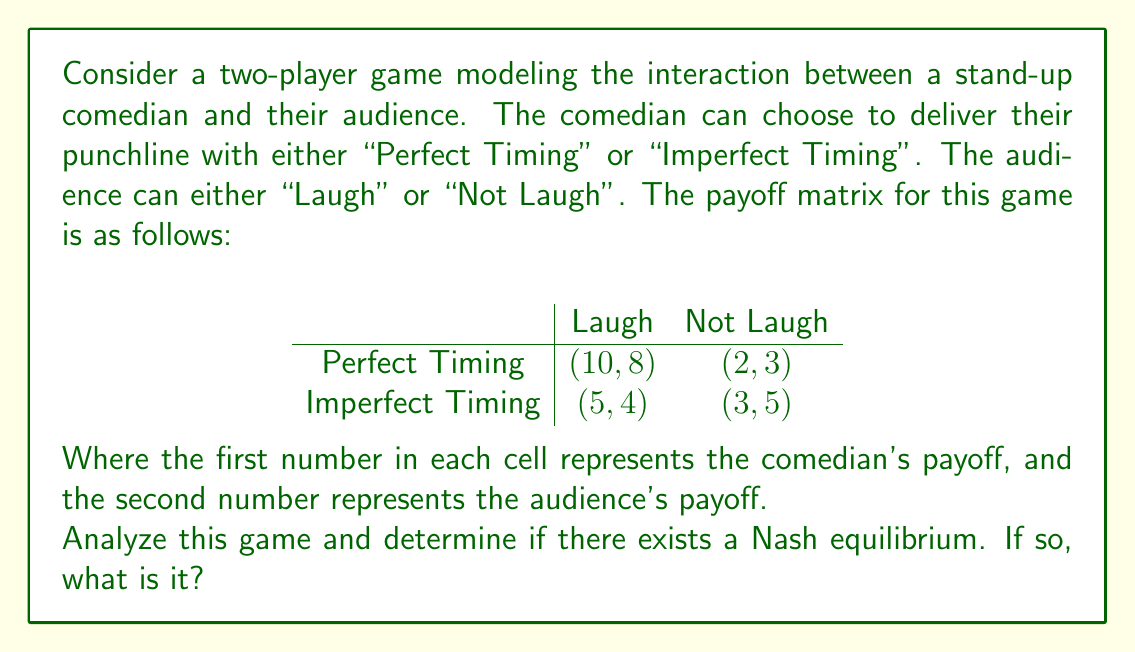Teach me how to tackle this problem. To solve this problem, we need to analyze the game using the concept of Nash equilibrium. A Nash equilibrium occurs when neither player can unilaterally improve their payoff by changing their strategy.

Let's examine each player's best responses:

1. Comedian's perspective:
   - If the audience laughs, Perfect Timing (10) > Imperfect Timing (5)
   - If the audience doesn't laugh, Imperfect Timing (3) > Perfect Timing (2)

2. Audience's perspective:
   - If the comedian uses Perfect Timing, Laugh (8) > Not Laugh (3)
   - If the comedian uses Imperfect Timing, Not Laugh (5) > Laugh (4)

Now, let's check for Nash equilibria:

a) (Perfect Timing, Laugh):
   - Comedian can't improve by switching to Imperfect Timing (10 > 5)
   - Audience can't improve by switching to Not Laugh (8 > 3)
   This is a Nash equilibrium.

b) (Perfect Timing, Not Laugh):
   - Comedian can improve by switching to Imperfect Timing (3 > 2)
   This is not a Nash equilibrium.

c) (Imperfect Timing, Laugh):
   - Comedian can improve by switching to Perfect Timing (10 > 5)
   This is not a Nash equilibrium.

d) (Imperfect Timing, Not Laugh):
   - Audience can improve by switching to Laugh (4 > 3)
   This is not a Nash equilibrium.

Therefore, there is only one Nash equilibrium in this game: (Perfect Timing, Laugh).

This equilibrium reflects the ideal scenario in comedy, where the comedian's perfect timing elicits laughter from the audience, maximizing both players' payoffs. It demonstrates the importance of timing in comedy and how it influences audience reactions, which aligns with the study of comedy's evolution across cultures.
Answer: The Nash equilibrium for this game is (Perfect Timing, Laugh), with payoffs (10, 8) for the comedian and audience, respectively. 